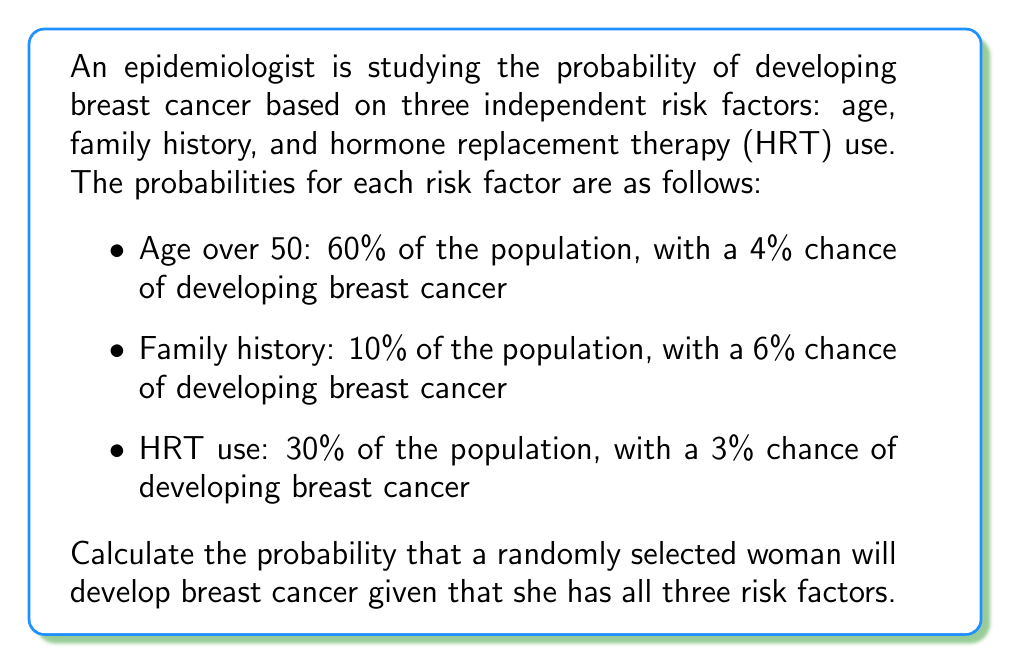Solve this math problem. To solve this problem, we need to use the concept of conditional probability and the multiplication rule for independent events.

1. Let's define the events:
   A: Age over 50
   F: Family history
   H: HRT use
   C: Developing breast cancer

2. We're given the following probabilities:
   $P(A) = 0.60$, $P(C|A) = 0.04$
   $P(F) = 0.10$, $P(C|F) = 0.06$
   $P(H) = 0.30$, $P(C|H) = 0.03$

3. We need to find $P(C|A \cap F \cap H)$, which is the probability of developing breast cancer given all three risk factors.

4. Using Bayes' theorem:
   $$P(C|A \cap F \cap H) = \frac{P(C \cap A \cap F \cap H)}{P(A \cap F \cap H)}$$

5. Since the events are independent:
   $$P(C \cap A \cap F \cap H) = P(C|A) \cdot P(C|F) \cdot P(C|H) \cdot P(A) \cdot P(F) \cdot P(H)$$
   $$P(A \cap F \cap H) = P(A) \cdot P(F) \cdot P(H)$$

6. Substituting the values:
   $$P(C|A \cap F \cap H) = \frac{0.04 \cdot 0.06 \cdot 0.03 \cdot 0.60 \cdot 0.10 \cdot 0.30}{0.60 \cdot 0.10 \cdot 0.30}$$

7. Simplifying:
   $$P(C|A \cap F \cap H) = 0.04 \cdot 0.06 \cdot 0.03 = 0.000072$$

8. Converting to a percentage:
   $$P(C|A \cap F \cap H) = 0.000072 \cdot 100\% = 0.0072\%$$
Answer: The probability that a randomly selected woman will develop breast cancer given that she has all three risk factors is 0.0072% or approximately 7.2 in 100,000. 